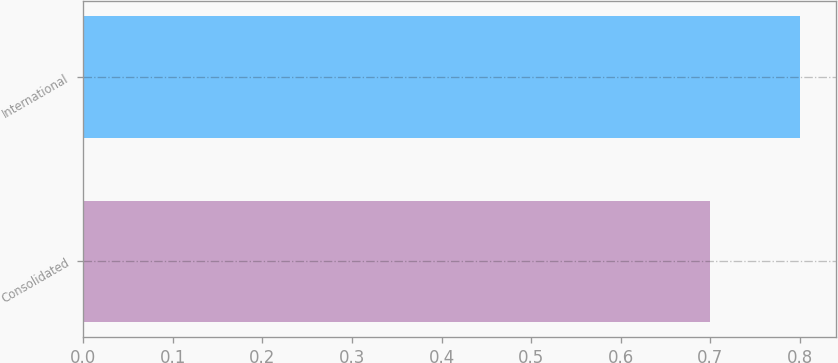Convert chart. <chart><loc_0><loc_0><loc_500><loc_500><bar_chart><fcel>Consolidated<fcel>International<nl><fcel>0.7<fcel>0.8<nl></chart> 